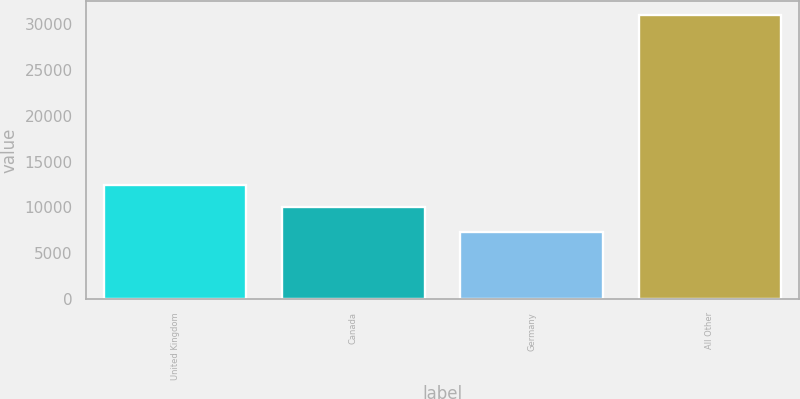Convert chart to OTSL. <chart><loc_0><loc_0><loc_500><loc_500><bar_chart><fcel>United Kingdom<fcel>Canada<fcel>Germany<fcel>All Other<nl><fcel>12393.4<fcel>10028<fcel>7322<fcel>30976<nl></chart> 